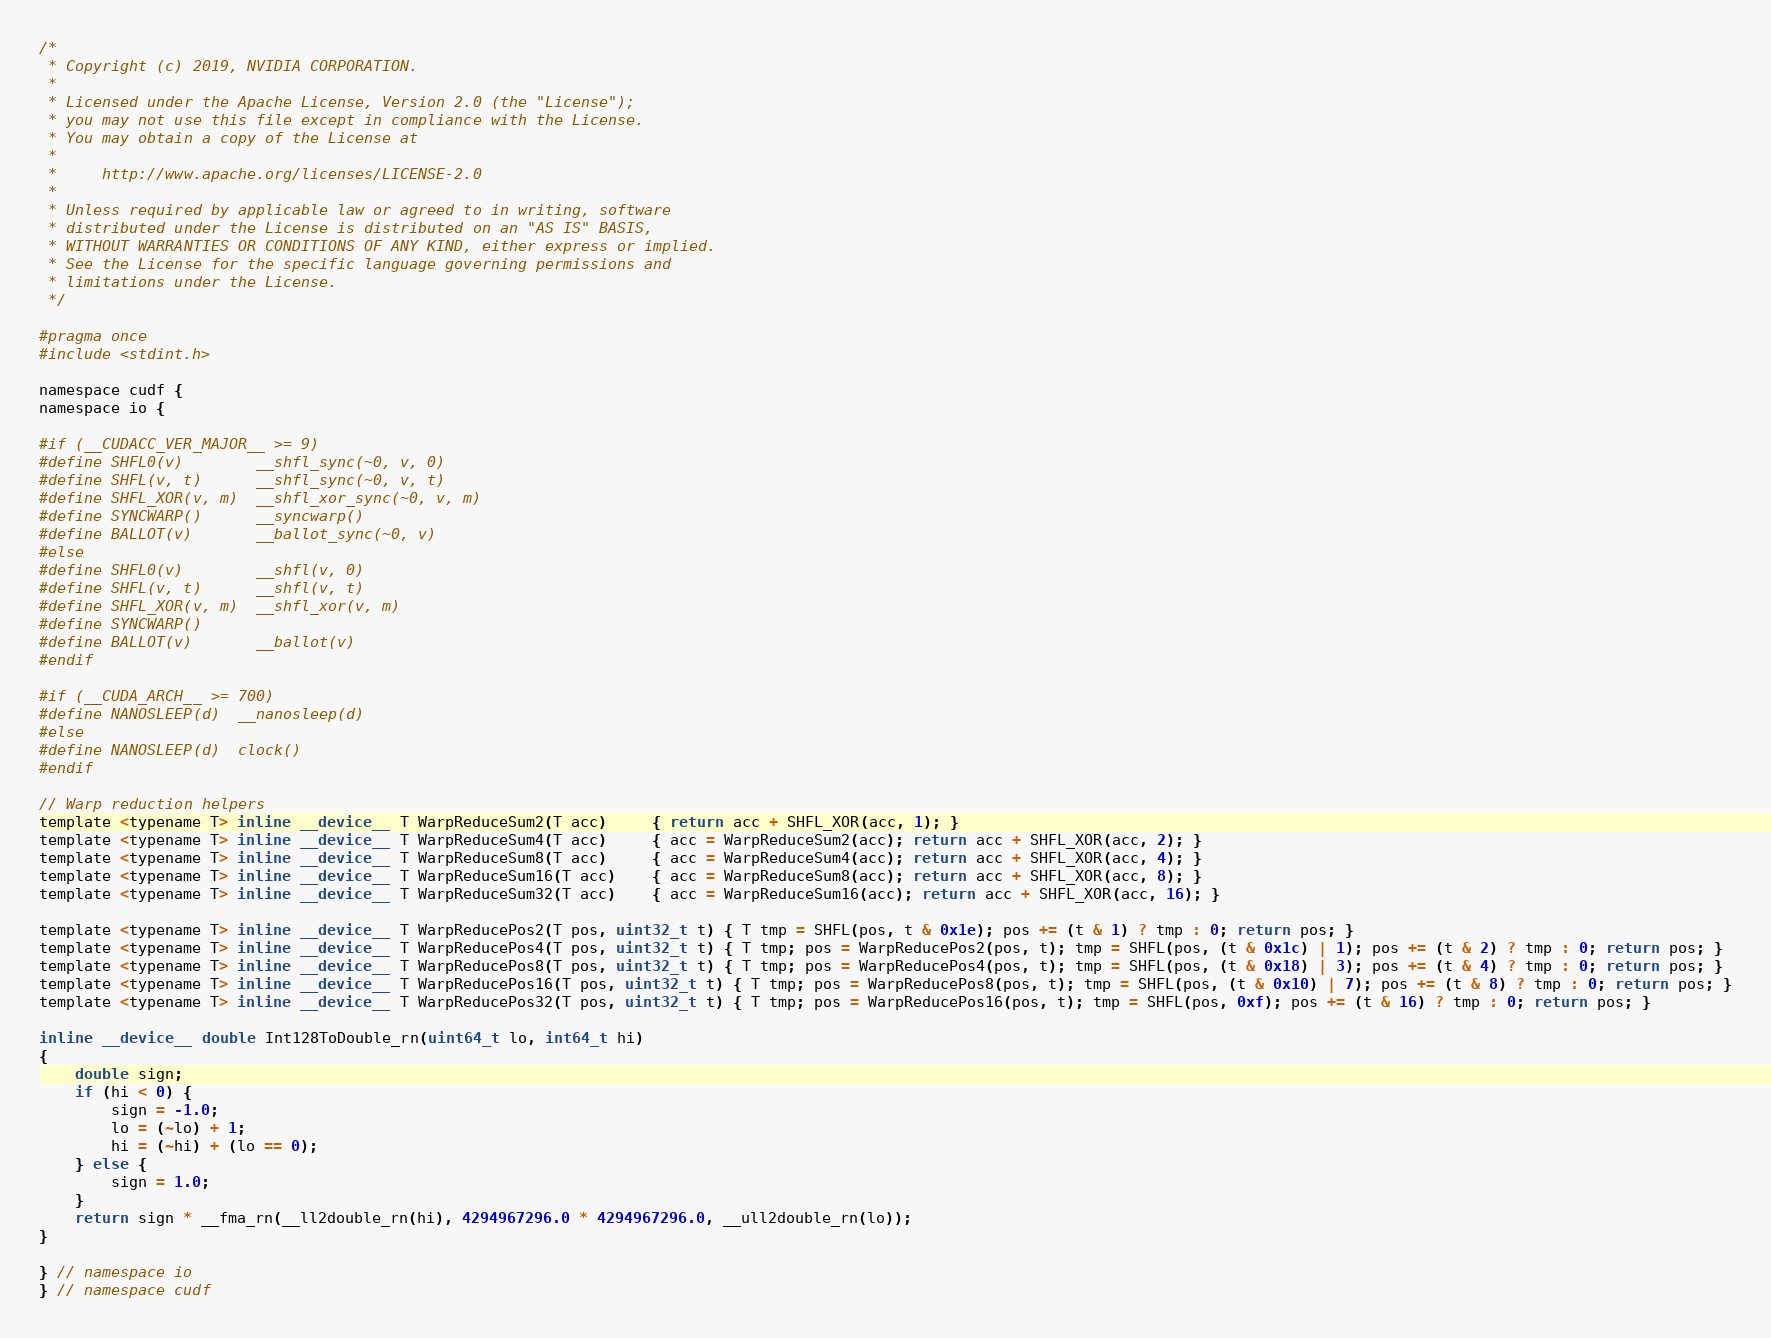<code> <loc_0><loc_0><loc_500><loc_500><_Cuda_>/*
 * Copyright (c) 2019, NVIDIA CORPORATION.
 *
 * Licensed under the Apache License, Version 2.0 (the "License");
 * you may not use this file except in compliance with the License.
 * You may obtain a copy of the License at
 *
 *     http://www.apache.org/licenses/LICENSE-2.0
 *
 * Unless required by applicable law or agreed to in writing, software
 * distributed under the License is distributed on an "AS IS" BASIS,
 * WITHOUT WARRANTIES OR CONDITIONS OF ANY KIND, either express or implied.
 * See the License for the specific language governing permissions and
 * limitations under the License.
 */

#pragma once
#include <stdint.h>

namespace cudf {
namespace io {

#if (__CUDACC_VER_MAJOR__ >= 9)
#define SHFL0(v)        __shfl_sync(~0, v, 0)
#define SHFL(v, t)      __shfl_sync(~0, v, t)
#define SHFL_XOR(v, m)  __shfl_xor_sync(~0, v, m)
#define SYNCWARP()      __syncwarp()
#define BALLOT(v)       __ballot_sync(~0, v)
#else
#define SHFL0(v)        __shfl(v, 0)
#define SHFL(v, t)      __shfl(v, t)
#define SHFL_XOR(v, m)  __shfl_xor(v, m)
#define SYNCWARP()
#define BALLOT(v)       __ballot(v)
#endif

#if (__CUDA_ARCH__ >= 700)
#define NANOSLEEP(d)  __nanosleep(d)
#else
#define NANOSLEEP(d)  clock()
#endif

// Warp reduction helpers
template <typename T> inline __device__ T WarpReduceSum2(T acc)     { return acc + SHFL_XOR(acc, 1); }
template <typename T> inline __device__ T WarpReduceSum4(T acc)     { acc = WarpReduceSum2(acc); return acc + SHFL_XOR(acc, 2); }
template <typename T> inline __device__ T WarpReduceSum8(T acc)     { acc = WarpReduceSum4(acc); return acc + SHFL_XOR(acc, 4); }
template <typename T> inline __device__ T WarpReduceSum16(T acc)    { acc = WarpReduceSum8(acc); return acc + SHFL_XOR(acc, 8); }
template <typename T> inline __device__ T WarpReduceSum32(T acc)    { acc = WarpReduceSum16(acc); return acc + SHFL_XOR(acc, 16); }

template <typename T> inline __device__ T WarpReducePos2(T pos, uint32_t t) { T tmp = SHFL(pos, t & 0x1e); pos += (t & 1) ? tmp : 0; return pos; }
template <typename T> inline __device__ T WarpReducePos4(T pos, uint32_t t) { T tmp; pos = WarpReducePos2(pos, t); tmp = SHFL(pos, (t & 0x1c) | 1); pos += (t & 2) ? tmp : 0; return pos; }
template <typename T> inline __device__ T WarpReducePos8(T pos, uint32_t t) { T tmp; pos = WarpReducePos4(pos, t); tmp = SHFL(pos, (t & 0x18) | 3); pos += (t & 4) ? tmp : 0; return pos; }
template <typename T> inline __device__ T WarpReducePos16(T pos, uint32_t t) { T tmp; pos = WarpReducePos8(pos, t); tmp = SHFL(pos, (t & 0x10) | 7); pos += (t & 8) ? tmp : 0; return pos; }
template <typename T> inline __device__ T WarpReducePos32(T pos, uint32_t t) { T tmp; pos = WarpReducePos16(pos, t); tmp = SHFL(pos, 0xf); pos += (t & 16) ? tmp : 0; return pos; }

inline __device__ double Int128ToDouble_rn(uint64_t lo, int64_t hi)
{
    double sign;
    if (hi < 0) {
        sign = -1.0;
        lo = (~lo) + 1;
        hi = (~hi) + (lo == 0);
    } else {
        sign = 1.0;
    }
    return sign * __fma_rn(__ll2double_rn(hi), 4294967296.0 * 4294967296.0, __ull2double_rn(lo));
}

} // namespace io
} // namespace cudf

</code> 